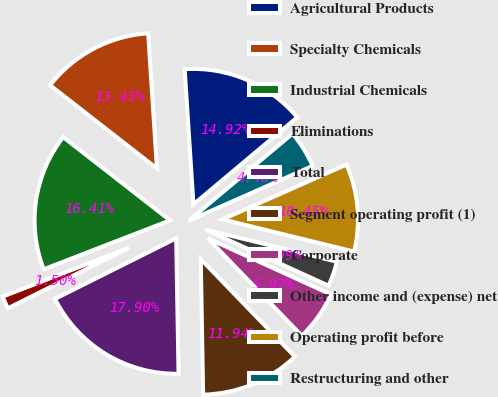Convert chart. <chart><loc_0><loc_0><loc_500><loc_500><pie_chart><fcel>Agricultural Products<fcel>Specialty Chemicals<fcel>Industrial Chemicals<fcel>Eliminations<fcel>Total<fcel>Segment operating profit (1)<fcel>Corporate<fcel>Other income and (expense) net<fcel>Operating profit before<fcel>Restructuring and other<nl><fcel>14.92%<fcel>13.43%<fcel>16.41%<fcel>1.5%<fcel>17.9%<fcel>11.94%<fcel>5.97%<fcel>2.99%<fcel>10.45%<fcel>4.48%<nl></chart> 